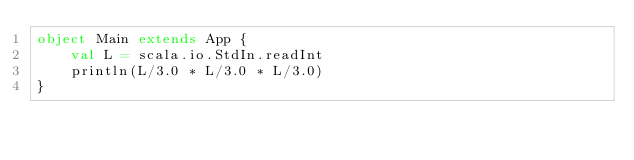<code> <loc_0><loc_0><loc_500><loc_500><_Scala_>object Main extends App {
	val L = scala.io.StdIn.readInt
	println(L/3.0 * L/3.0 * L/3.0)
}</code> 